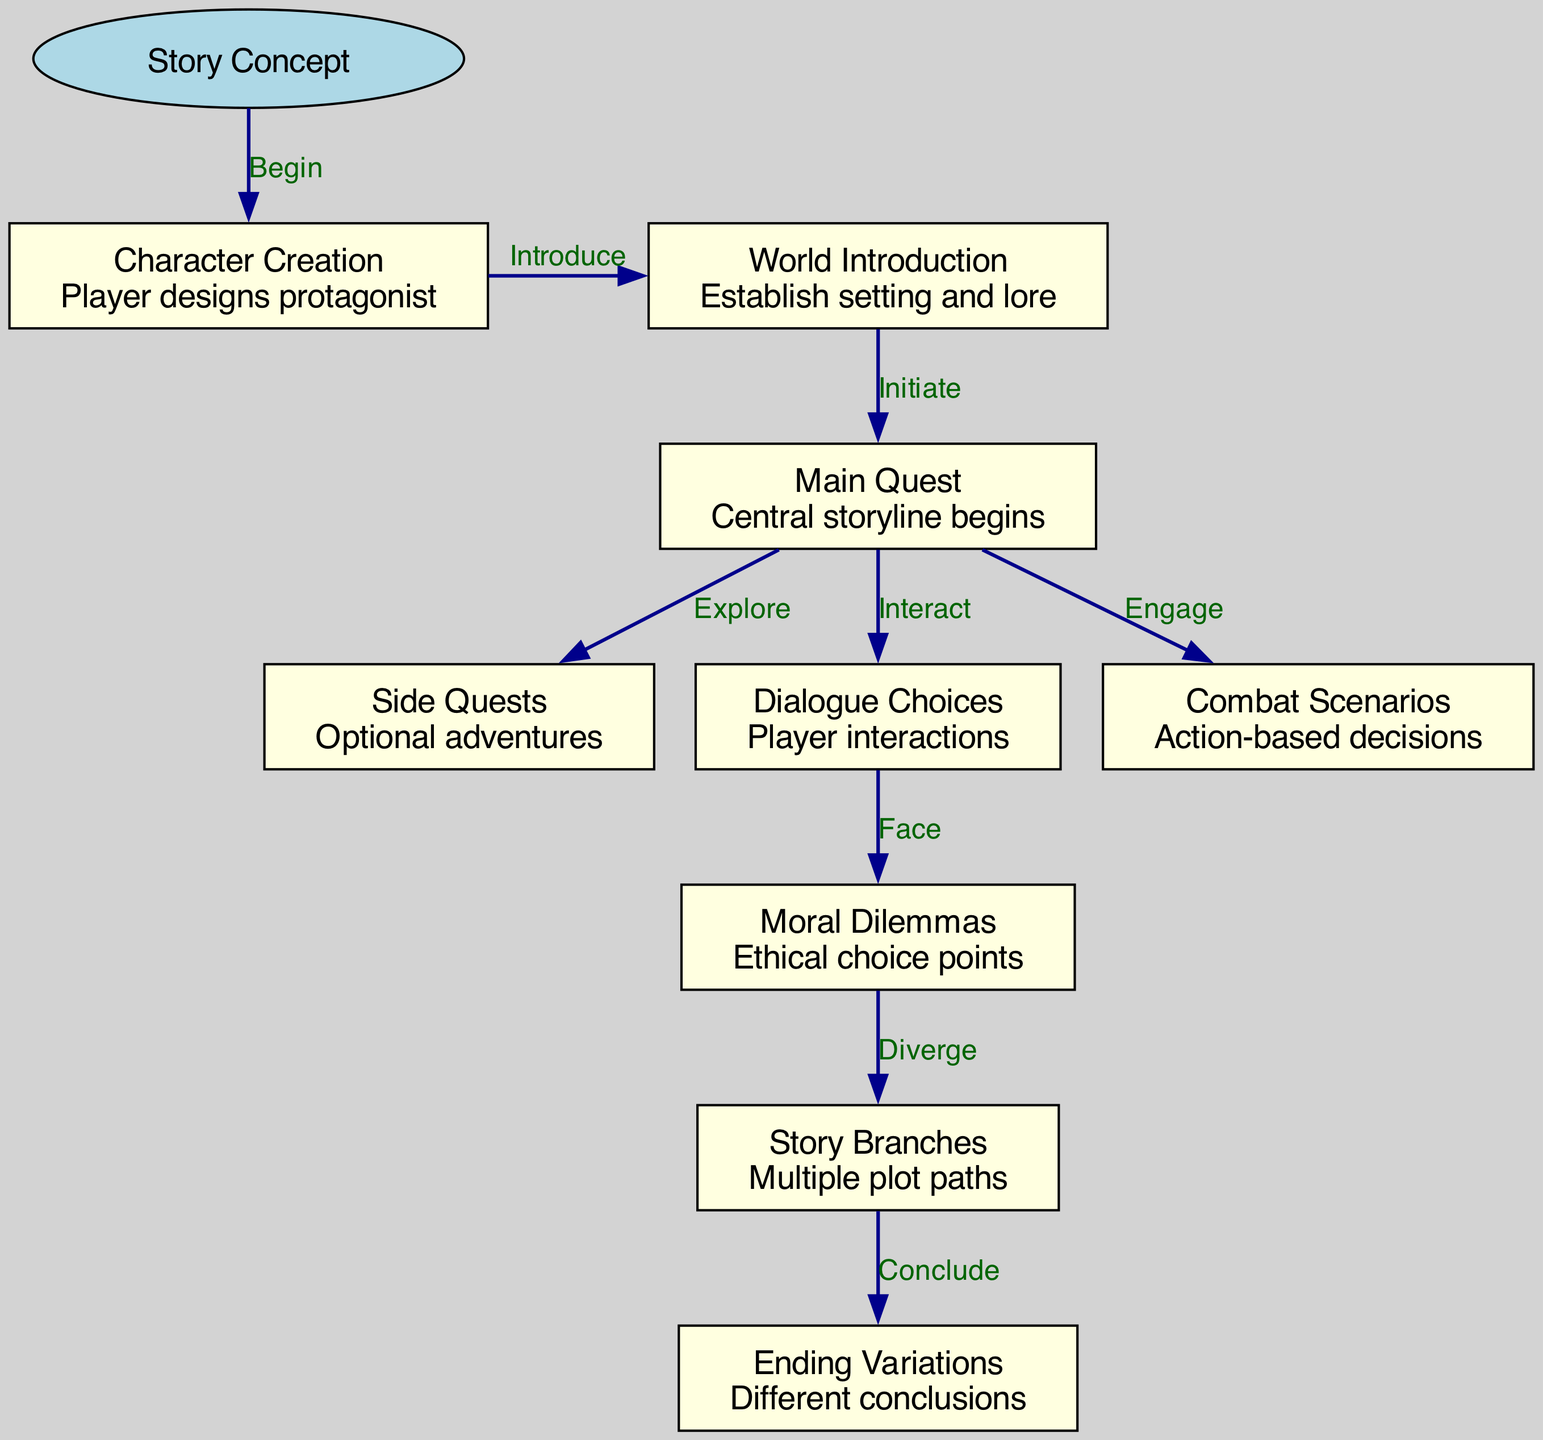What is the starting point of the diagram? The diagram originates from a node labeled "Story Concept," which is indicated as the starting point.
Answer: Story Concept How many main quest nodes are present? There is only one main quest node labeled "Main Quest."
Answer: 1 What type of choices does the player encounter after "Dialogue Choices"? Following the "Dialogue Choices" node, players face "Moral Dilemmas," as indicated by the edge leading to that node.
Answer: Moral Dilemmas Which node contains the "Ending Variations"? The "Ending Variations" are found in the last node labeled "Ending Variations" in the flowchart.
Answer: Ending Variations From which node does the "Combat Scenarios" branch? "Combat Scenarios" branches out directly from the "Main Quest" node, as shown by the edge connecting them.
Answer: Main Quest What is the relationship between "Moral Dilemmas" and "Story Branches"? The "Moral Dilemmas" node leads into the "Story Branches" node, indicating a divergence based on ethical decision-making.
Answer: Diverge How many edges connect to the "Character Creation" node? The "Character Creation" node has one outgoing edge connecting it to "World Introduction," making the total count of edges one.
Answer: 1 Which node is the last step in the pathway? The final node in the pathway is "Ending Variations," which concludes the narrative journey as per the diagram.
Answer: Ending Variations What are the three options a player has directly after the "Main Quest"? The player can either engage in "Side Quests," "Dialogue Choices," or "Combat Scenarios" directly after the "Main Quest."
Answer: Side Quests, Dialogue Choices, Combat Scenarios 